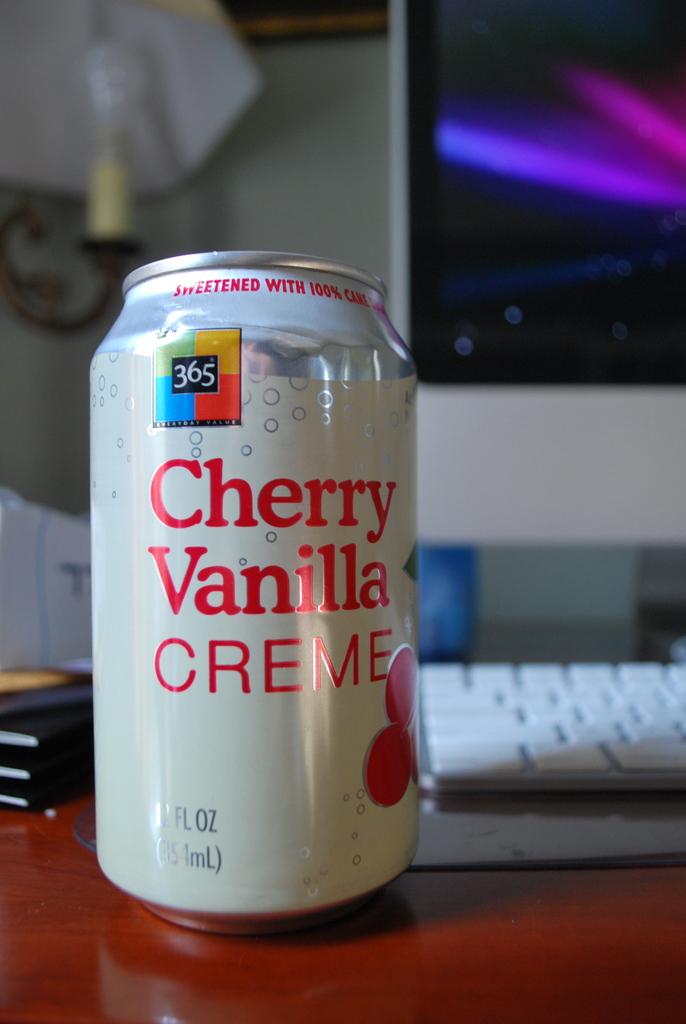What type of drink is that?
Ensure brevity in your answer.  Cherry vanilla creme. 